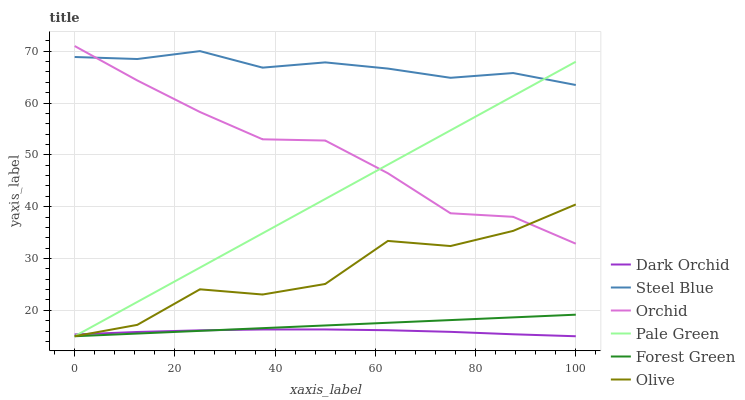Does Dark Orchid have the minimum area under the curve?
Answer yes or no. Yes. Does Steel Blue have the maximum area under the curve?
Answer yes or no. Yes. Does Forest Green have the minimum area under the curve?
Answer yes or no. No. Does Forest Green have the maximum area under the curve?
Answer yes or no. No. Is Forest Green the smoothest?
Answer yes or no. Yes. Is Olive the roughest?
Answer yes or no. Yes. Is Dark Orchid the smoothest?
Answer yes or no. No. Is Dark Orchid the roughest?
Answer yes or no. No. Does Dark Orchid have the lowest value?
Answer yes or no. Yes. Does Orchid have the lowest value?
Answer yes or no. No. Does Orchid have the highest value?
Answer yes or no. Yes. Does Forest Green have the highest value?
Answer yes or no. No. Is Forest Green less than Orchid?
Answer yes or no. Yes. Is Orchid greater than Forest Green?
Answer yes or no. Yes. Does Olive intersect Orchid?
Answer yes or no. Yes. Is Olive less than Orchid?
Answer yes or no. No. Is Olive greater than Orchid?
Answer yes or no. No. Does Forest Green intersect Orchid?
Answer yes or no. No. 